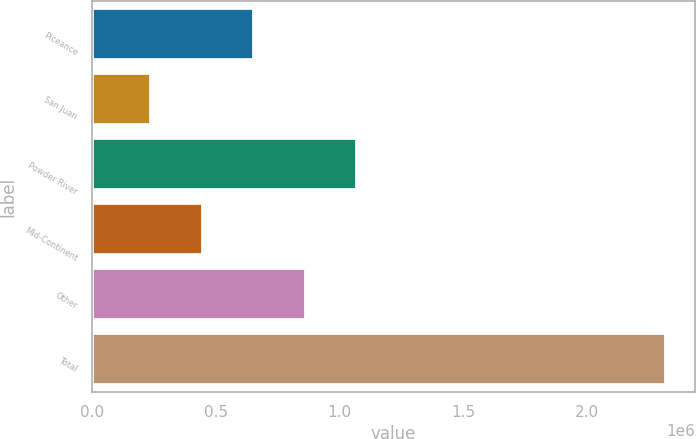Convert chart to OTSL. <chart><loc_0><loc_0><loc_500><loc_500><bar_chart><fcel>Piceance<fcel>San Juan<fcel>Powder River<fcel>Mid-Continent<fcel>Other<fcel>Total<nl><fcel>655283<fcel>239688<fcel>1.07088e+06<fcel>447486<fcel>863081<fcel>2.31766e+06<nl></chart> 